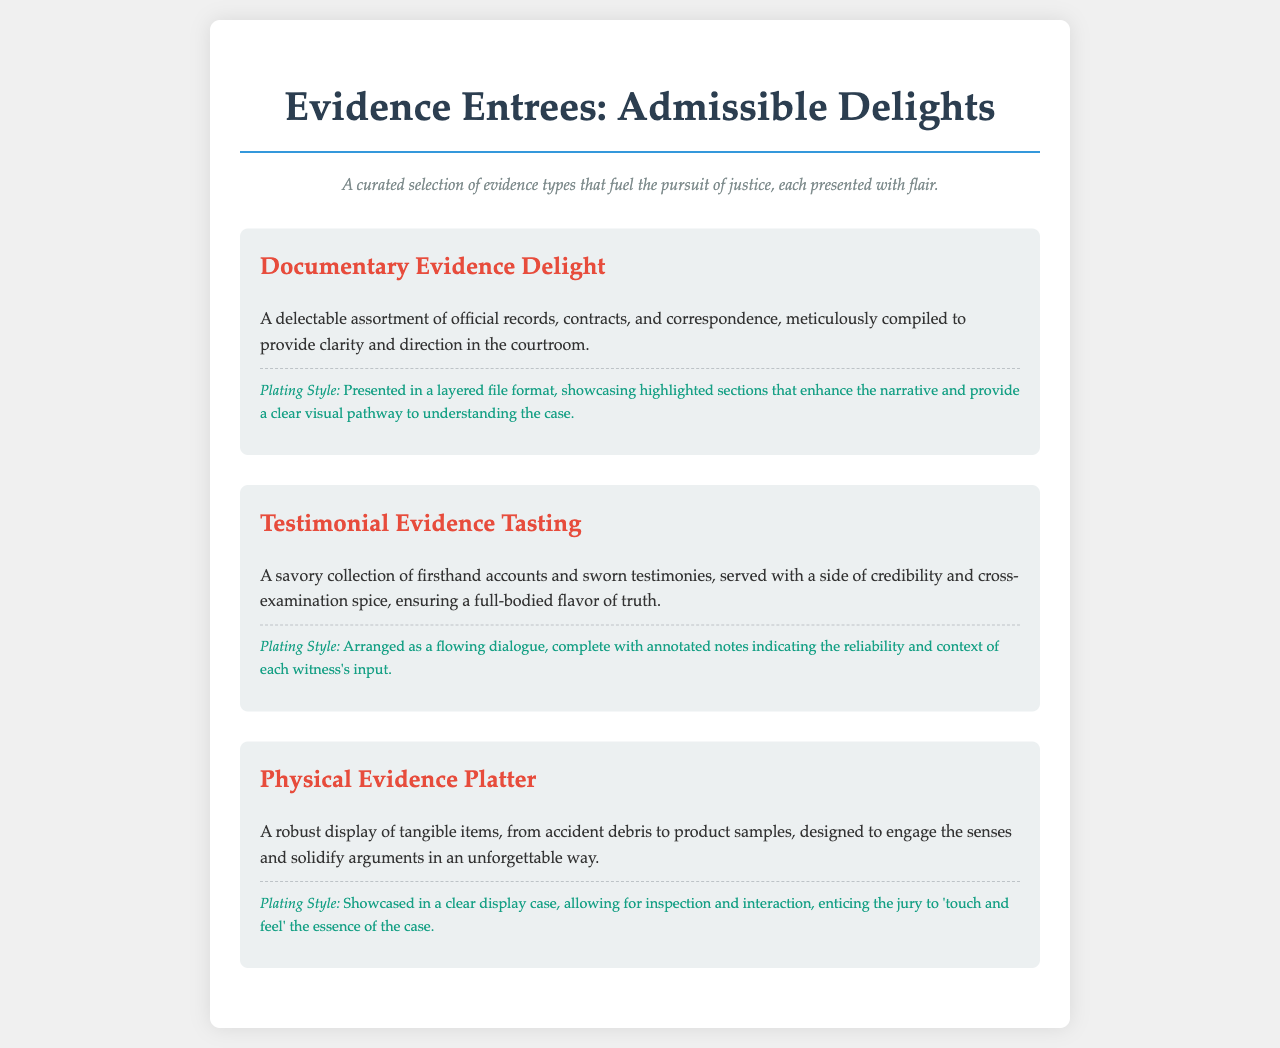what is the title of the menu? The title of the menu is displayed prominently at the top of the document.
Answer: Evidence Entrees: Admissible Delights how many types of evidence are featured in the menu? The menu lists three specific types of evidence in its descriptions.
Answer: 3 what type of evidence is the first entree? The first entree is described right below the title and explains the kind of evidence it represents.
Answer: Documentary Evidence Delight what is a key characteristic of Testimonial Evidence Tasting? The description highlights a unique aspect that enhances the understanding of this type of evidence.
Answer: Firsthand accounts how is the Physical Evidence Platter presented? The plating style mentioned provides insight into the visual and interactive approach of the presentation.
Answer: Clear display case what scholarly role does the Documentary Evidence Delight play? The description indicates the purpose of the evidence type within a legal context.
Answer: Clarity and direction what flavor is associated with the Testimonial Evidence Tasting? The description uses a culinary metaphor to enhance the conceptual understanding of this evidence type.
Answer: Full-bodied flavor of truth what is the plating style of the Documentary Evidence Delight? The document specifically describes how this evidence type is visually arranged.
Answer: Layered file format 